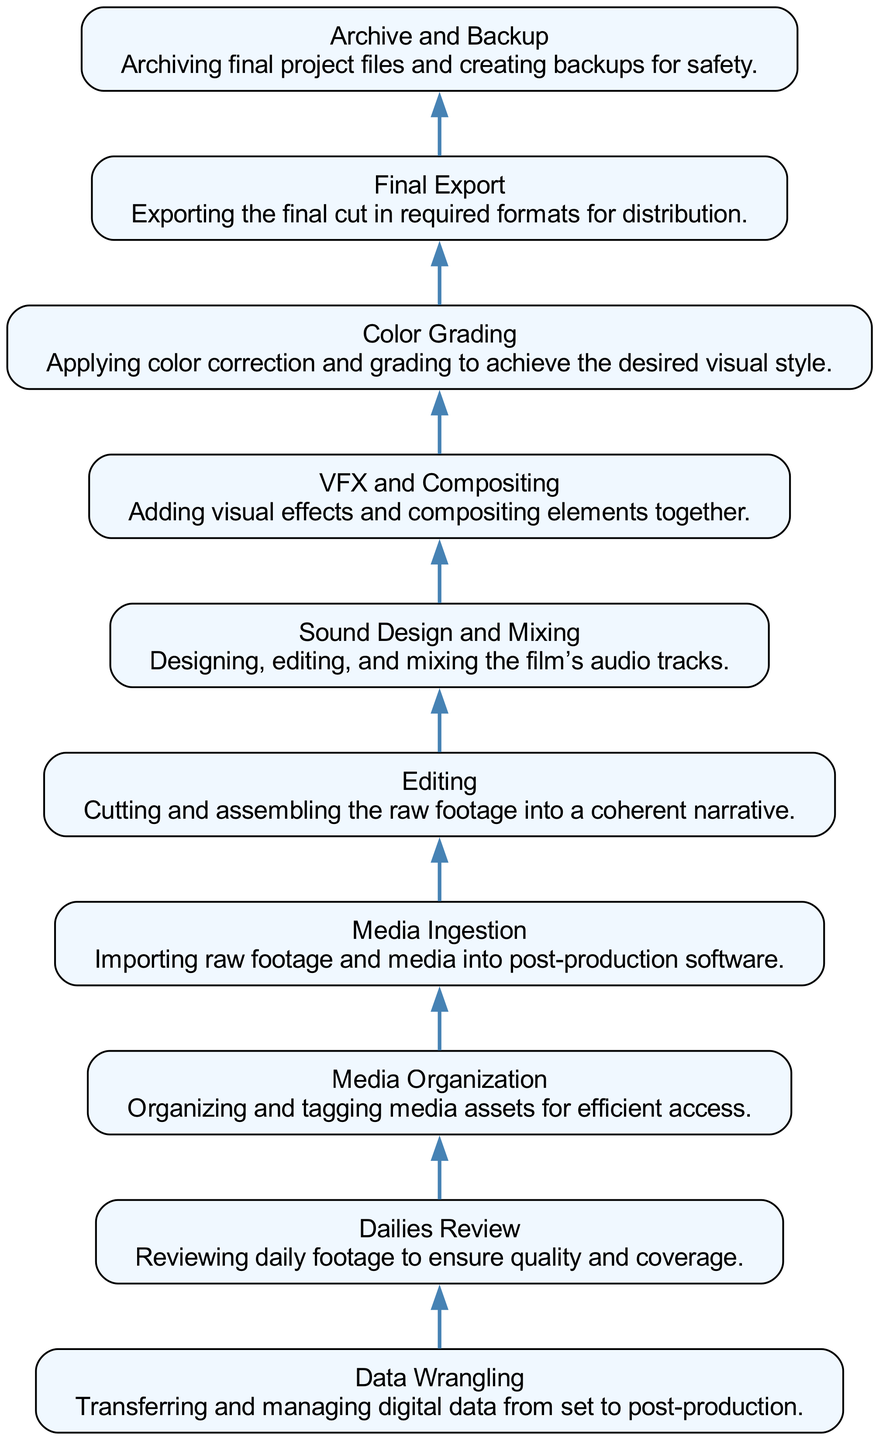What is the first step in the post-production workflow? The first step in the diagram is "Data Wrangling," which is the starting point before any other processes.
Answer: Data Wrangling How many steps are there in the post-production workflow? The diagram shows a total of 10 distinct steps in the workflow, which can be counted by looking at the nodes listed from bottom to top.
Answer: 10 Which process comes immediately before Color Grading? The process that precedes "Color Grading" is "VFX and Compositing" as indicated by the direct connection in the flow of the diagram.
Answer: VFX and Compositing What is the final step in this workflow? The final step in the workflow is "Archive and Backup," as it is the end node with no subsequent steps leading out of it.
Answer: Archive and Backup If the workflow starts at "Data Wrangling," which step would follow after "Editing"? Following "Editing," the next step is "Sound Design and Mixing," as the diagram illustrates the flow from "Editing" to "Sound Design and Mixing."
Answer: Sound Design and Mixing What describes the relationship between "Final Export" and "Color Grading"? "Final Export" is the step that comes after "Color Grading" in the workflow; this indicates that color grading must be completed before the final export can occur.
Answer: Final Export follows Color Grading How does “Media Organization” relate to “Dailies Review”? "Media Organization" is the necessary step that comes after "Dailies Review," showing that organizing the media is essential before moving onto editing.
Answer: Media Organization follows Dailies Review What is the process that occurs immediately after "Media Ingestion"? The process directly after "Media Ingestion" is "Editing," as indicated in the step flow of the post-production process.
Answer: Editing What step requires checking quality and coverage? The step that necessitates reviewing quality and coverage is "Dailies Review," which is specifically focused on ensuring the footage meets required standards.
Answer: Dailies Review 